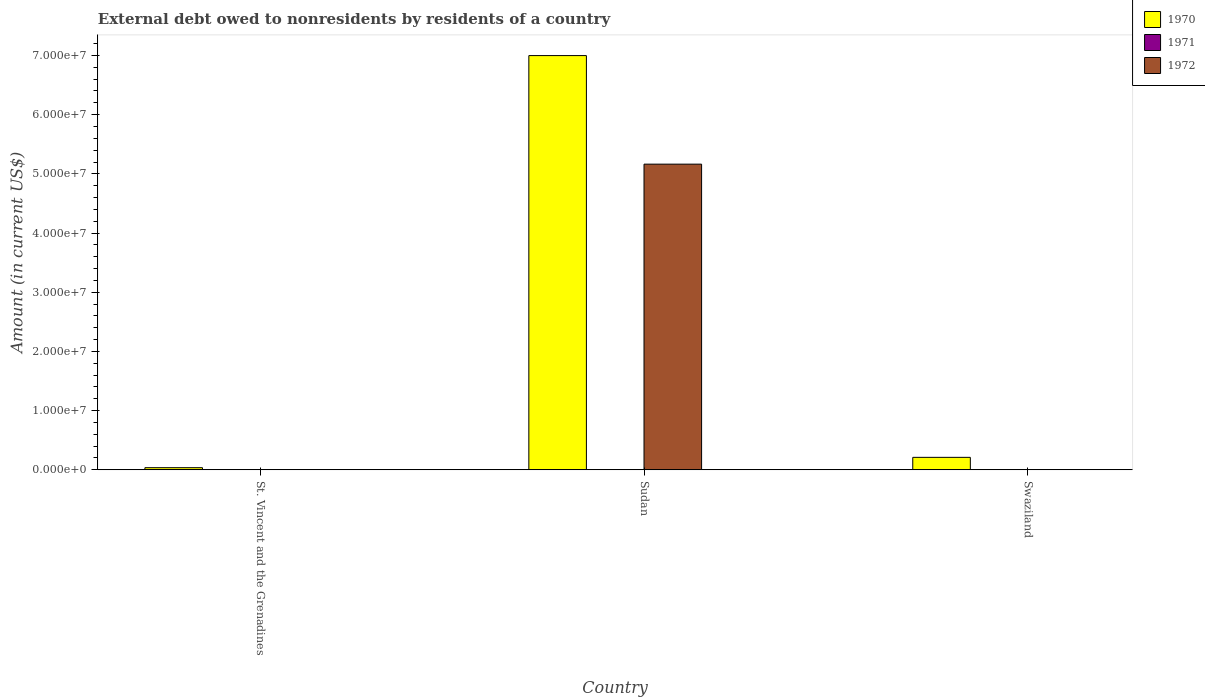How many different coloured bars are there?
Make the answer very short. 3. Are the number of bars per tick equal to the number of legend labels?
Your response must be concise. No. Are the number of bars on each tick of the X-axis equal?
Give a very brief answer. No. How many bars are there on the 2nd tick from the left?
Give a very brief answer. 2. How many bars are there on the 3rd tick from the right?
Provide a short and direct response. 3. What is the label of the 3rd group of bars from the left?
Keep it short and to the point. Swaziland. In how many cases, is the number of bars for a given country not equal to the number of legend labels?
Your answer should be compact. 2. What is the external debt owed by residents in 1971 in Sudan?
Provide a succinct answer. 0. Across all countries, what is the maximum external debt owed by residents in 1970?
Make the answer very short. 7.00e+07. In which country was the external debt owed by residents in 1971 maximum?
Offer a very short reply. St. Vincent and the Grenadines. What is the total external debt owed by residents in 1970 in the graph?
Provide a short and direct response. 7.24e+07. What is the difference between the external debt owed by residents in 1970 in St. Vincent and the Grenadines and that in Swaziland?
Offer a terse response. -1.74e+06. What is the difference between the external debt owed by residents in 1970 in Sudan and the external debt owed by residents in 1972 in Swaziland?
Ensure brevity in your answer.  7.00e+07. What is the average external debt owed by residents in 1970 per country?
Offer a terse response. 2.41e+07. What is the difference between the external debt owed by residents of/in 1970 and external debt owed by residents of/in 1971 in St. Vincent and the Grenadines?
Your response must be concise. 3.57e+05. What is the ratio of the external debt owed by residents in 1970 in St. Vincent and the Grenadines to that in Sudan?
Give a very brief answer. 0.01. Is the external debt owed by residents in 1970 in St. Vincent and the Grenadines less than that in Sudan?
Offer a terse response. Yes. What is the difference between the highest and the second highest external debt owed by residents in 1970?
Make the answer very short. 6.96e+07. What is the difference between the highest and the lowest external debt owed by residents in 1970?
Ensure brevity in your answer.  6.96e+07. In how many countries, is the external debt owed by residents in 1972 greater than the average external debt owed by residents in 1972 taken over all countries?
Your answer should be compact. 1. Is it the case that in every country, the sum of the external debt owed by residents in 1971 and external debt owed by residents in 1970 is greater than the external debt owed by residents in 1972?
Your response must be concise. Yes. How many bars are there?
Your answer should be very brief. 6. How many countries are there in the graph?
Give a very brief answer. 3. Are the values on the major ticks of Y-axis written in scientific E-notation?
Ensure brevity in your answer.  Yes. Does the graph contain any zero values?
Provide a succinct answer. Yes. Does the graph contain grids?
Offer a very short reply. No. Where does the legend appear in the graph?
Offer a terse response. Top right. How are the legend labels stacked?
Ensure brevity in your answer.  Vertical. What is the title of the graph?
Make the answer very short. External debt owed to nonresidents by residents of a country. Does "1988" appear as one of the legend labels in the graph?
Keep it short and to the point. No. What is the label or title of the X-axis?
Provide a succinct answer. Country. What is the Amount (in current US$) in 1971 in St. Vincent and the Grenadines?
Make the answer very short. 3000. What is the Amount (in current US$) of 1972 in St. Vincent and the Grenadines?
Your answer should be very brief. 1.50e+04. What is the Amount (in current US$) of 1970 in Sudan?
Your response must be concise. 7.00e+07. What is the Amount (in current US$) in 1972 in Sudan?
Ensure brevity in your answer.  5.16e+07. What is the Amount (in current US$) of 1970 in Swaziland?
Provide a succinct answer. 2.10e+06. What is the Amount (in current US$) of 1971 in Swaziland?
Offer a terse response. 0. Across all countries, what is the maximum Amount (in current US$) in 1970?
Ensure brevity in your answer.  7.00e+07. Across all countries, what is the maximum Amount (in current US$) in 1971?
Make the answer very short. 3000. Across all countries, what is the maximum Amount (in current US$) in 1972?
Provide a succinct answer. 5.16e+07. Across all countries, what is the minimum Amount (in current US$) of 1970?
Ensure brevity in your answer.  3.60e+05. Across all countries, what is the minimum Amount (in current US$) in 1972?
Provide a succinct answer. 0. What is the total Amount (in current US$) of 1970 in the graph?
Your answer should be compact. 7.24e+07. What is the total Amount (in current US$) in 1971 in the graph?
Provide a succinct answer. 3000. What is the total Amount (in current US$) in 1972 in the graph?
Make the answer very short. 5.17e+07. What is the difference between the Amount (in current US$) in 1970 in St. Vincent and the Grenadines and that in Sudan?
Offer a terse response. -6.96e+07. What is the difference between the Amount (in current US$) in 1972 in St. Vincent and the Grenadines and that in Sudan?
Give a very brief answer. -5.16e+07. What is the difference between the Amount (in current US$) in 1970 in St. Vincent and the Grenadines and that in Swaziland?
Ensure brevity in your answer.  -1.74e+06. What is the difference between the Amount (in current US$) of 1970 in Sudan and that in Swaziland?
Provide a short and direct response. 6.79e+07. What is the difference between the Amount (in current US$) of 1970 in St. Vincent and the Grenadines and the Amount (in current US$) of 1972 in Sudan?
Give a very brief answer. -5.13e+07. What is the difference between the Amount (in current US$) of 1971 in St. Vincent and the Grenadines and the Amount (in current US$) of 1972 in Sudan?
Offer a terse response. -5.16e+07. What is the average Amount (in current US$) of 1970 per country?
Your response must be concise. 2.41e+07. What is the average Amount (in current US$) of 1972 per country?
Provide a succinct answer. 1.72e+07. What is the difference between the Amount (in current US$) of 1970 and Amount (in current US$) of 1971 in St. Vincent and the Grenadines?
Provide a succinct answer. 3.57e+05. What is the difference between the Amount (in current US$) in 1970 and Amount (in current US$) in 1972 in St. Vincent and the Grenadines?
Keep it short and to the point. 3.45e+05. What is the difference between the Amount (in current US$) of 1971 and Amount (in current US$) of 1972 in St. Vincent and the Grenadines?
Keep it short and to the point. -1.20e+04. What is the difference between the Amount (in current US$) of 1970 and Amount (in current US$) of 1972 in Sudan?
Offer a very short reply. 1.83e+07. What is the ratio of the Amount (in current US$) in 1970 in St. Vincent and the Grenadines to that in Sudan?
Make the answer very short. 0.01. What is the ratio of the Amount (in current US$) of 1972 in St. Vincent and the Grenadines to that in Sudan?
Offer a very short reply. 0. What is the ratio of the Amount (in current US$) of 1970 in St. Vincent and the Grenadines to that in Swaziland?
Ensure brevity in your answer.  0.17. What is the ratio of the Amount (in current US$) in 1970 in Sudan to that in Swaziland?
Make the answer very short. 33.24. What is the difference between the highest and the second highest Amount (in current US$) of 1970?
Offer a very short reply. 6.79e+07. What is the difference between the highest and the lowest Amount (in current US$) in 1970?
Provide a succinct answer. 6.96e+07. What is the difference between the highest and the lowest Amount (in current US$) of 1971?
Keep it short and to the point. 3000. What is the difference between the highest and the lowest Amount (in current US$) of 1972?
Keep it short and to the point. 5.16e+07. 